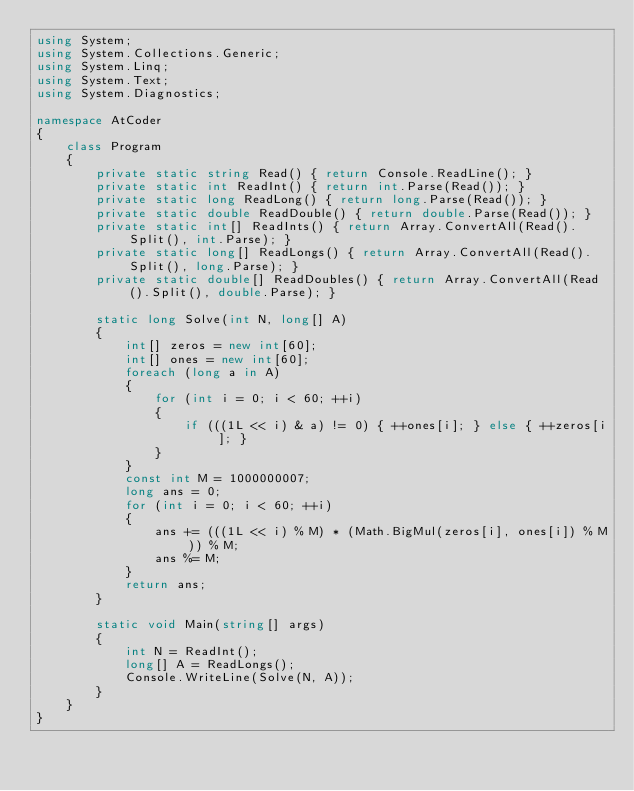<code> <loc_0><loc_0><loc_500><loc_500><_C#_>using System;
using System.Collections.Generic;
using System.Linq;
using System.Text;
using System.Diagnostics;

namespace AtCoder
{
    class Program
    {
        private static string Read() { return Console.ReadLine(); }
        private static int ReadInt() { return int.Parse(Read()); }
        private static long ReadLong() { return long.Parse(Read()); }
        private static double ReadDouble() { return double.Parse(Read()); }
        private static int[] ReadInts() { return Array.ConvertAll(Read().Split(), int.Parse); }
        private static long[] ReadLongs() { return Array.ConvertAll(Read().Split(), long.Parse); }
        private static double[] ReadDoubles() { return Array.ConvertAll(Read().Split(), double.Parse); }

        static long Solve(int N, long[] A)
        {
            int[] zeros = new int[60];
            int[] ones = new int[60];
            foreach (long a in A)
            {
                for (int i = 0; i < 60; ++i)
                {
                    if (((1L << i) & a) != 0) { ++ones[i]; } else { ++zeros[i]; }
                }
            }
            const int M = 1000000007;
            long ans = 0;
            for (int i = 0; i < 60; ++i)
            {
                ans += (((1L << i) % M) * (Math.BigMul(zeros[i], ones[i]) % M)) % M;
                ans %= M;
            }
            return ans;
        }

        static void Main(string[] args)
        {
            int N = ReadInt();
            long[] A = ReadLongs();
            Console.WriteLine(Solve(N, A));
        }
    }
}
</code> 